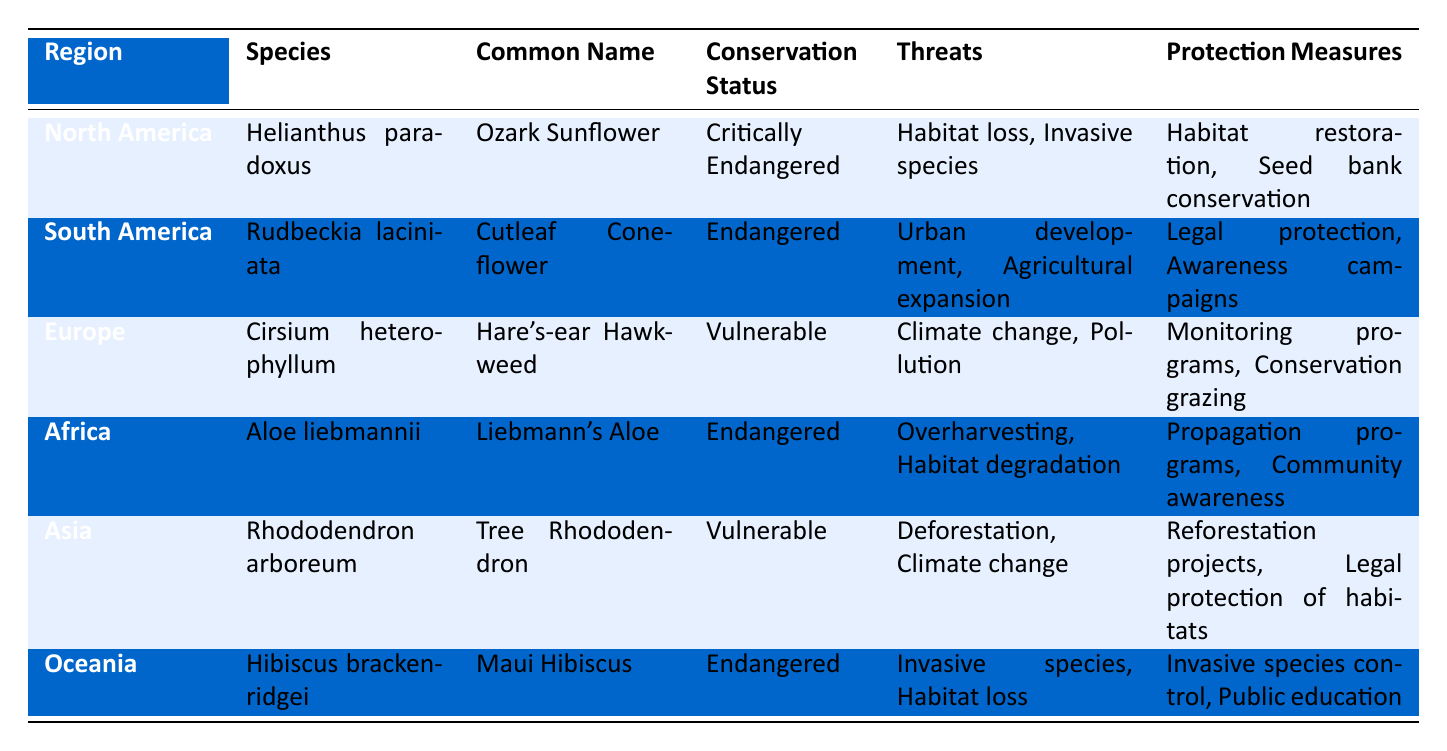What is the conservation status of the Ozark Sunflower? Referring to the table, the Ozark Sunflower, which is represented under North America, is listed with a conservation status of "Critically Endangered."
Answer: Critically Endangered Which plant species in Africa is classified as Endangered? The table indicates that in Africa, the plant species classified as Endangered is Aloe liebmannii, which is also known as Liebmann's Aloe.
Answer: Aloe liebmannii How many species are categorized as Vulnerable? The table presents two species categorized as Vulnerable: Cirsium heterophyllum from Europe and Rhododendron arboreum from Asia. Therefore, the count of Vulnerable species is 2.
Answer: 2 Which region has the highest number of conservation threats listed? A detailed look reveals that the species from Africa (Aloe liebmannii) and Oceania (Hibiscus brackenridgei) each have two threats listed (overharvesting and habitat degradation for Aloe; invasive species and habitat loss for Hibiscus), while others have varying counts. Hence, the regions with the highest number of threats (2) are Africa and Oceania.
Answer: Africa and Oceania Is there a species that faces habitat loss as a threat? Yes, the table shows that both Helianthus paradoxus (Ozark Sunflower) and Hibiscus brackenridgei (Maui Hibiscus) face habitat loss as a threat.
Answer: Yes What is the common name of the species from North America with a critically endangered status? The common name listed for the species Helianthus paradoxus, which is from North America and is critically endangered, is Ozark Sunflower.
Answer: Ozark Sunflower What protection measures are proposed for the Cutleaf Coneflower? The table indicates that the protection measures proposed for Rudbeckia laciniata (Cutleaf Coneflower) include legal protection and awareness campaigns.
Answer: Legal protection and awareness campaigns Which regions have species classified as Endangered, and how many are there? Referring to the table, there are two species classified as Endangered: Rudbeckia laciniata from South America and Aloe liebmannii from Africa. The regions with Endangered species are South America and Africa.
Answer: South America and Africa; 2 species What is the primary threat for the Hare's-ear Hawkweed? The table lists the threats for Cirsium heterophyllum (Hare's-ear Hawkweed) as climate change and pollution, with climate change being a primary threat.
Answer: Climate change List all protection measures for the Maui Hibiscus. The table indicates that for Hibiscus brackenridgei (Maui Hibiscus), the protection measures are invasive species control and public education.
Answer: Invasive species control and public education 